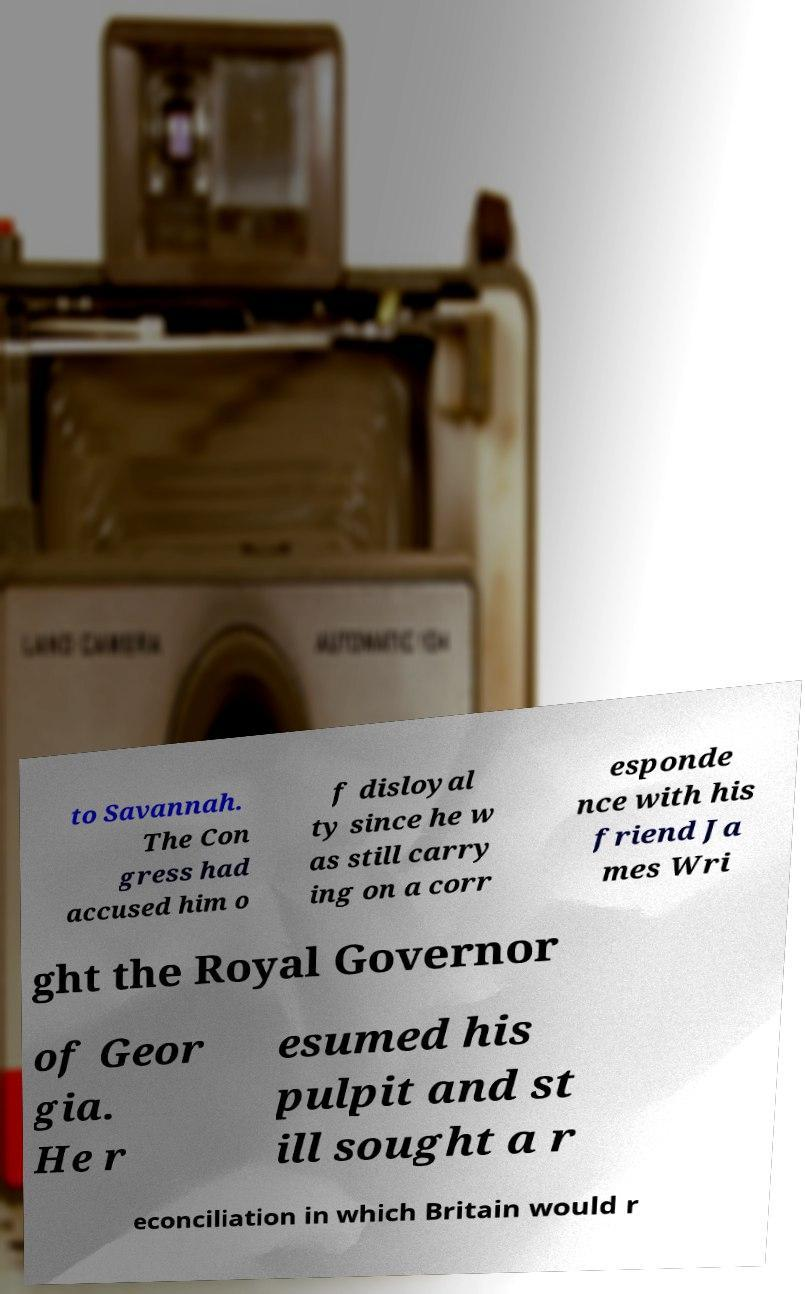Could you assist in decoding the text presented in this image and type it out clearly? to Savannah. The Con gress had accused him o f disloyal ty since he w as still carry ing on a corr esponde nce with his friend Ja mes Wri ght the Royal Governor of Geor gia. He r esumed his pulpit and st ill sought a r econciliation in which Britain would r 